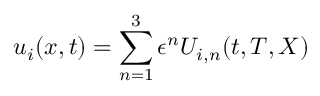<formula> <loc_0><loc_0><loc_500><loc_500>u _ { i } ( x , t ) = \sum _ { n = 1 } ^ { 3 } \epsilon ^ { n } U _ { i , n } ( t , T , X )</formula> 